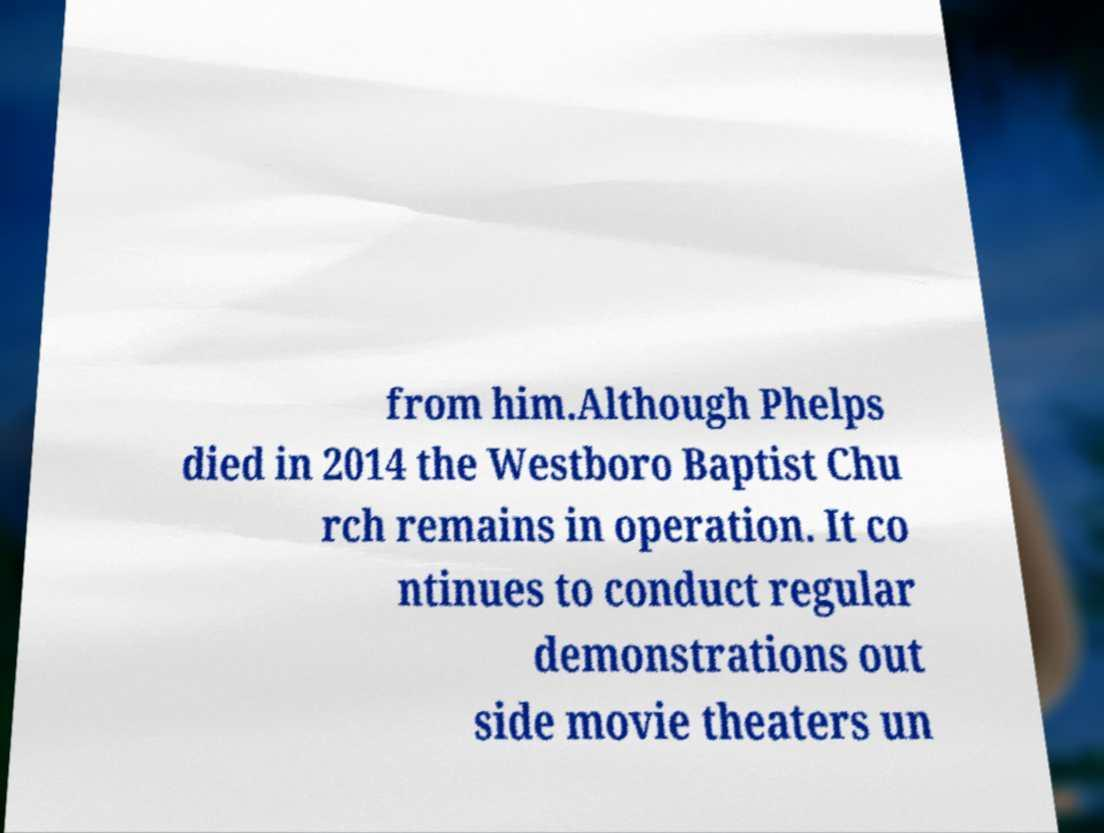Can you read and provide the text displayed in the image?This photo seems to have some interesting text. Can you extract and type it out for me? from him.Although Phelps died in 2014 the Westboro Baptist Chu rch remains in operation. It co ntinues to conduct regular demonstrations out side movie theaters un 